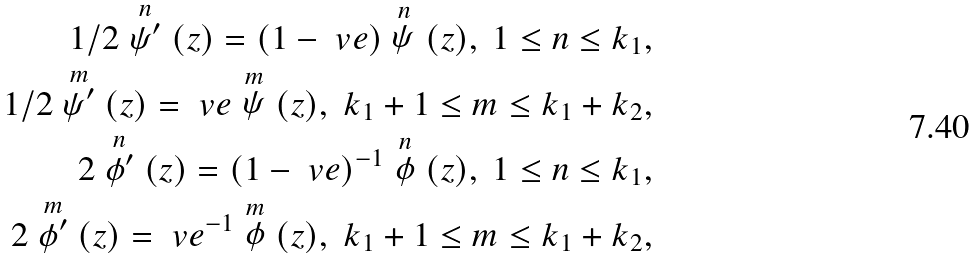Convert formula to latex. <formula><loc_0><loc_0><loc_500><loc_500>1 / 2 \stackrel { n } { \psi ^ { \prime } } ( z ) = ( 1 - \ v e ) \stackrel { n } { \psi } ( z ) , \ 1 \leq n \leq k _ { 1 } , \\ 1 / 2 \stackrel { m } { \psi ^ { \prime } } ( z ) = \ v e \stackrel { m } { \psi } ( z ) , \ k _ { 1 } + 1 \leq m \leq k _ { 1 } + k _ { 2 } , \\ 2 \stackrel { n } { \phi ^ { \prime } } ( z ) = ( 1 - \ v e ) ^ { - 1 } \stackrel { n } { \phi } ( z ) , \ 1 \leq n \leq k _ { 1 } , \\ 2 \stackrel { m } { \phi ^ { \prime } } ( z ) = \ v e ^ { - 1 } \stackrel { m } { \phi } ( z ) , \ k _ { 1 } + 1 \leq m \leq k _ { 1 } + k _ { 2 } ,</formula> 